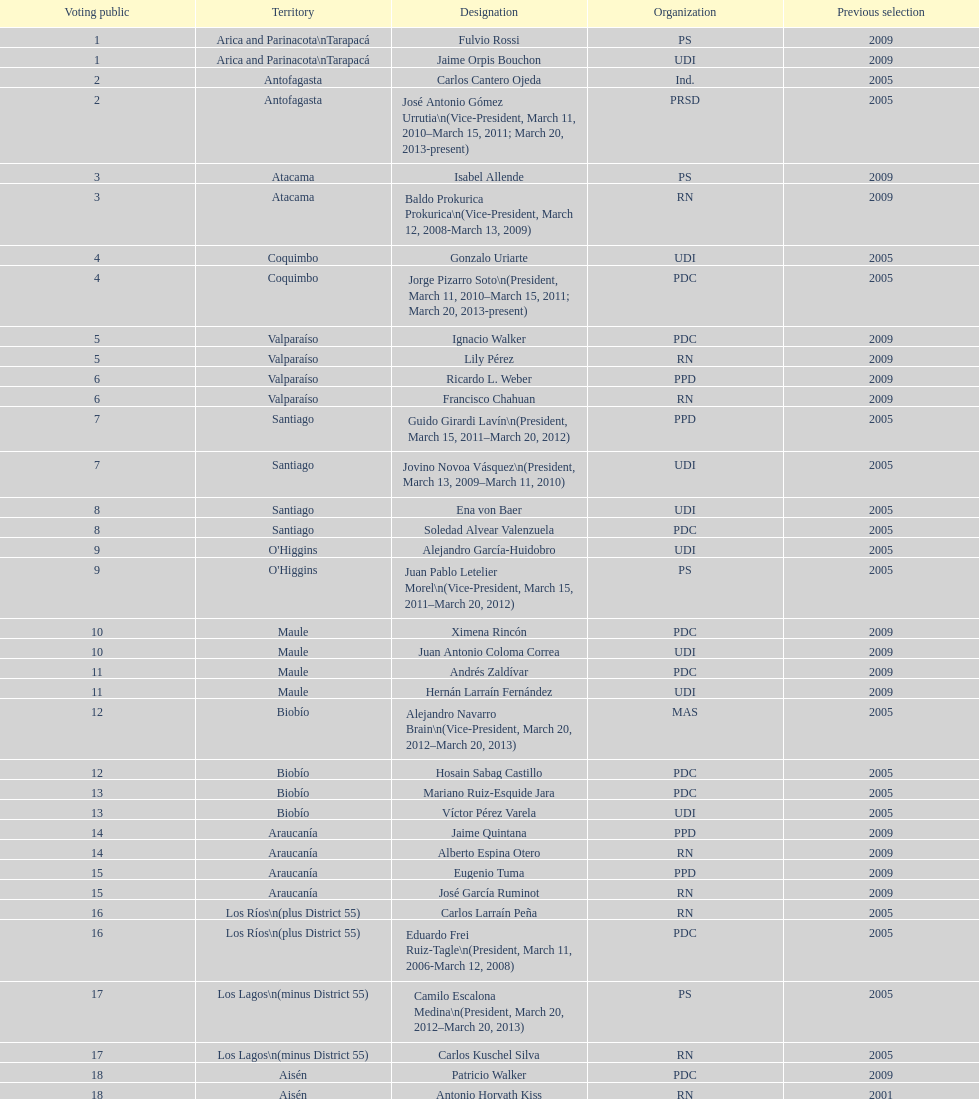What is the last region listed on the table? Magallanes. 